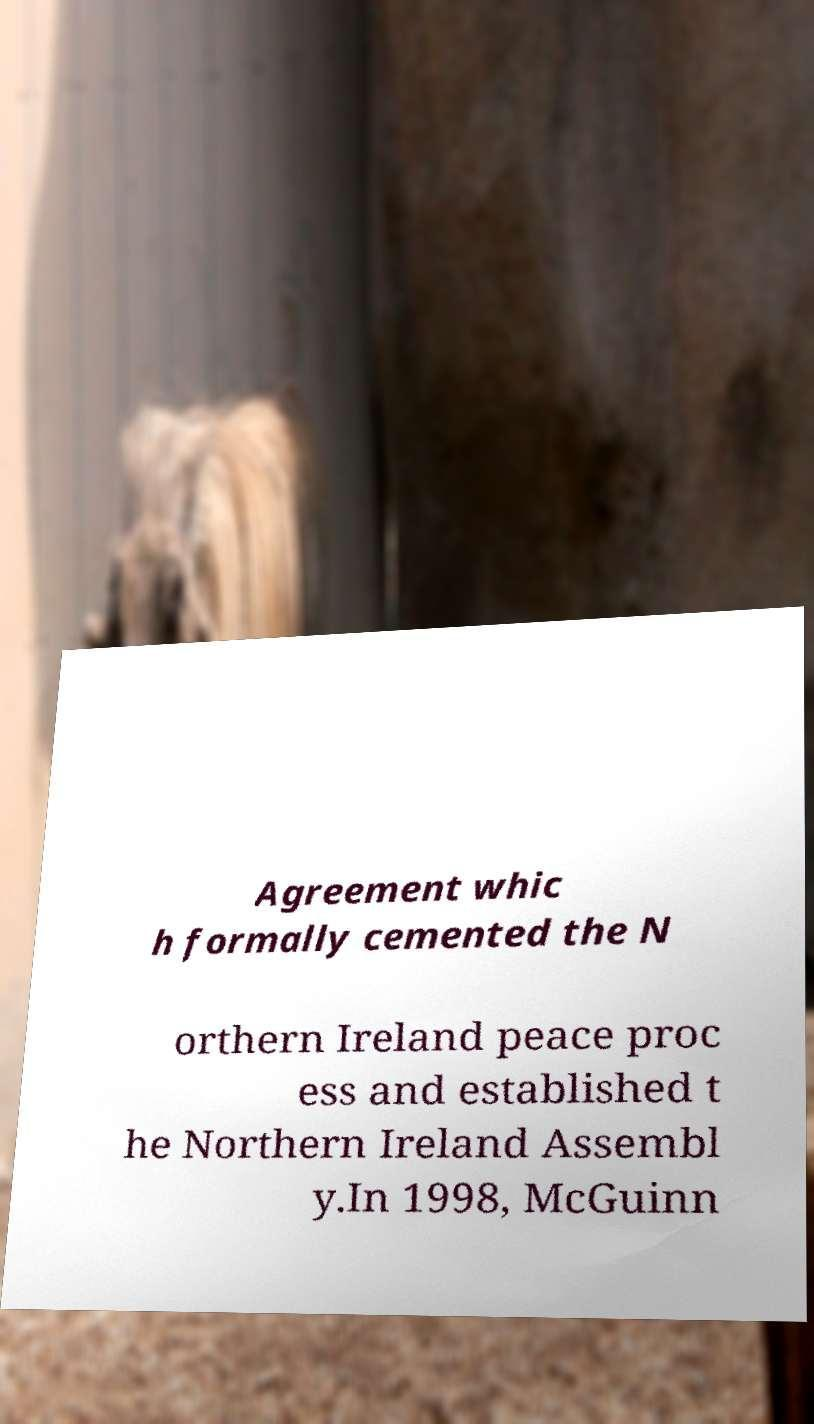What messages or text are displayed in this image? I need them in a readable, typed format. Agreement whic h formally cemented the N orthern Ireland peace proc ess and established t he Northern Ireland Assembl y.In 1998, McGuinn 